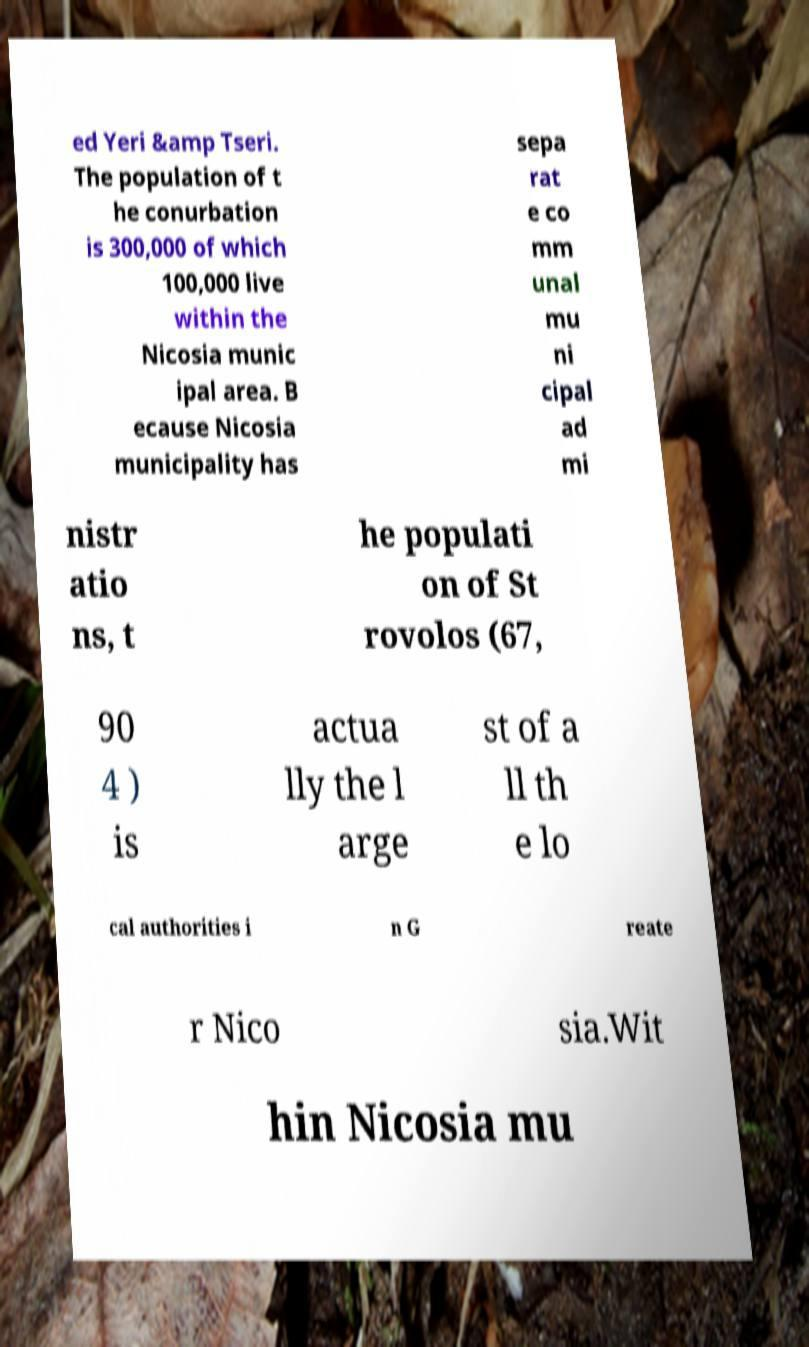For documentation purposes, I need the text within this image transcribed. Could you provide that? ed Yeri &amp Tseri. The population of t he conurbation is 300,000 of which 100,000 live within the Nicosia munic ipal area. B ecause Nicosia municipality has sepa rat e co mm unal mu ni cipal ad mi nistr atio ns, t he populati on of St rovolos (67, 90 4 ) is actua lly the l arge st of a ll th e lo cal authorities i n G reate r Nico sia.Wit hin Nicosia mu 